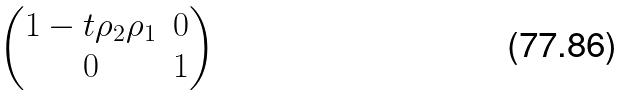Convert formula to latex. <formula><loc_0><loc_0><loc_500><loc_500>\begin{pmatrix} 1 - t \rho _ { 2 } \rho _ { 1 } & 0 \\ 0 & 1 \end{pmatrix}</formula> 